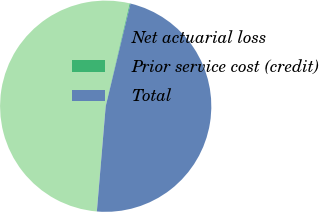Convert chart. <chart><loc_0><loc_0><loc_500><loc_500><pie_chart><fcel>Net actuarial loss<fcel>Prior service cost (credit)<fcel>Total<nl><fcel>52.32%<fcel>0.12%<fcel>47.56%<nl></chart> 